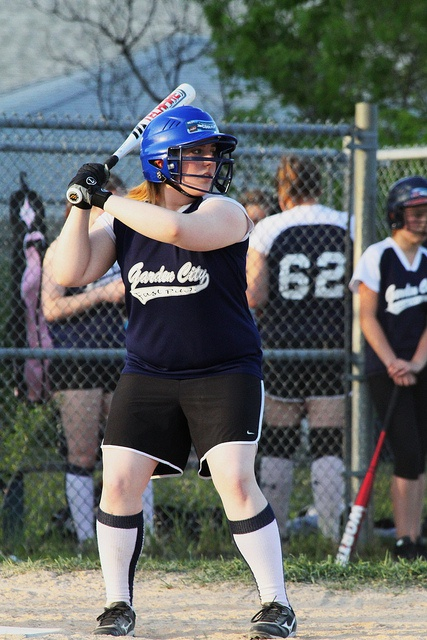Describe the objects in this image and their specific colors. I can see people in darkgray, black, lightgray, and gray tones, people in darkgray, black, gray, and lightgray tones, people in darkgray, black, gray, and lavender tones, people in darkgray, black, and gray tones, and baseball bat in darkgray, black, maroon, brown, and lightgray tones in this image. 